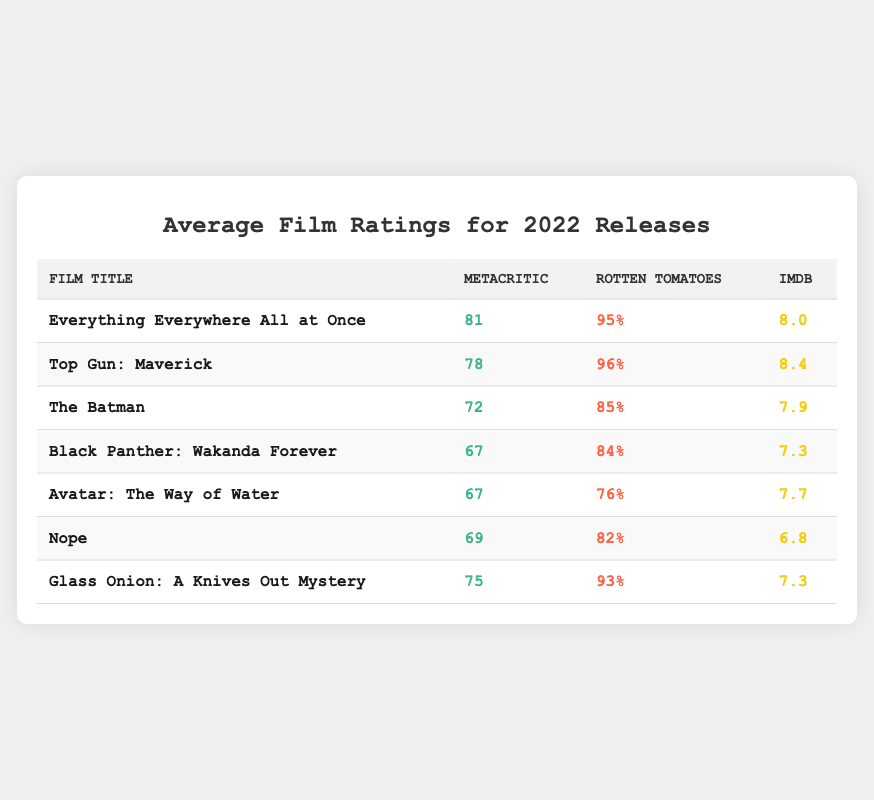What is the IMDb rating of "Top Gun: Maverick"? The IMDb rating for "Top Gun: Maverick" is located in the last column for that specific film. By looking at the table, we can see that it is 8.4.
Answer: 8.4 Which film has the highest Rotten Tomatoes rating? To determine which film has the highest Rotten Tomatoes rating, we need to compare the percentages in that column. "Top Gun: Maverick" has a rating of 96%, which is the highest among all films listed.
Answer: Top Gun: Maverick What is the average Metacritic rating of the films listed? To find the average Metacritic rating, we sum the Metacritic ratings: 81 + 78 + 72 + 67 + 67 + 69 + 75 = 509. There are 7 films, so we divide by 7: 509 / 7 = 72.71.
Answer: 72.71 Is "Everything Everywhere All at Once" rated higher than "Nope" on Rotten Tomatoes? "Everything Everywhere All at Once" has a Rotten Tomatoes rating of 95%, while "Nope" has a rating of 82%. Since 95% is greater than 82%, "Everything Everywhere All at Once" is indeed rated higher.
Answer: Yes What is the difference between the highest and lowest IMDb ratings in the table? The highest IMDb rating is 8.4 for "Top Gun: Maverick," and the lowest is 6.8 for "Nope." To find the difference, we subtract the lowest rating from the highest: 8.4 - 6.8 = 1.6.
Answer: 1.6 Which film has the lowest Metacritic rating and what is that rating? Looking through the Metacritic ratings, "Black Panther: Wakanda Forever" and "Avatar: The Way of Water" both have the lowest rating of 67. However, since they are the same, we can simply identify one of them.
Answer: Black Panther: Wakanda Forever, 67 Are there more films released in 2022 with IMDb ratings above 7.5 or below? "Everything Everywhere All at Once," "Top Gun: Maverick," and "The Batman" have IMDb ratings above 7.5 (8.0, 8.4, and 7.9), which totals 3 films. "Black Panther: Wakanda Forever," "Avatar: The Way of Water," "Nope," and "Glass Onion: A Knives Out Mystery" have ratings below 7.5 (7.3, 7.7, 6.8, and 7.3), totaling 4 films. Therefore, there are more films below 7.5.
Answer: Below 7.5 What are the Rotten Tomatoes ratings for "The Batman" and "Avatar: The Way of Water"? "The Batman" has a Rotten Tomatoes rating of 85%, and "Avatar: The Way of Water" has a rating of 76%. Both ratings can be directly obtained from the table in their respective rows.
Answer: 85%, 76% What is the average rating across all review platforms (Metacritic, Rotten Tomatoes, and IMDb) for "Glass Onion: A Knives Out Mystery"? To find the average rating for "Glass Onion: A Knives Out Mystery", we first convert Rotten Tomatoes percentage to a value out of 10: 93% becomes 9.3. Now we calculate the average: (75 + 9.3 + 7.3) / 3 = 30.6 / 3 = 10.2.
Answer: 10.2 